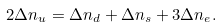Convert formula to latex. <formula><loc_0><loc_0><loc_500><loc_500>2 \Delta n _ { u } = \Delta n _ { d } + \Delta n _ { s } + 3 \Delta n _ { e } .</formula> 